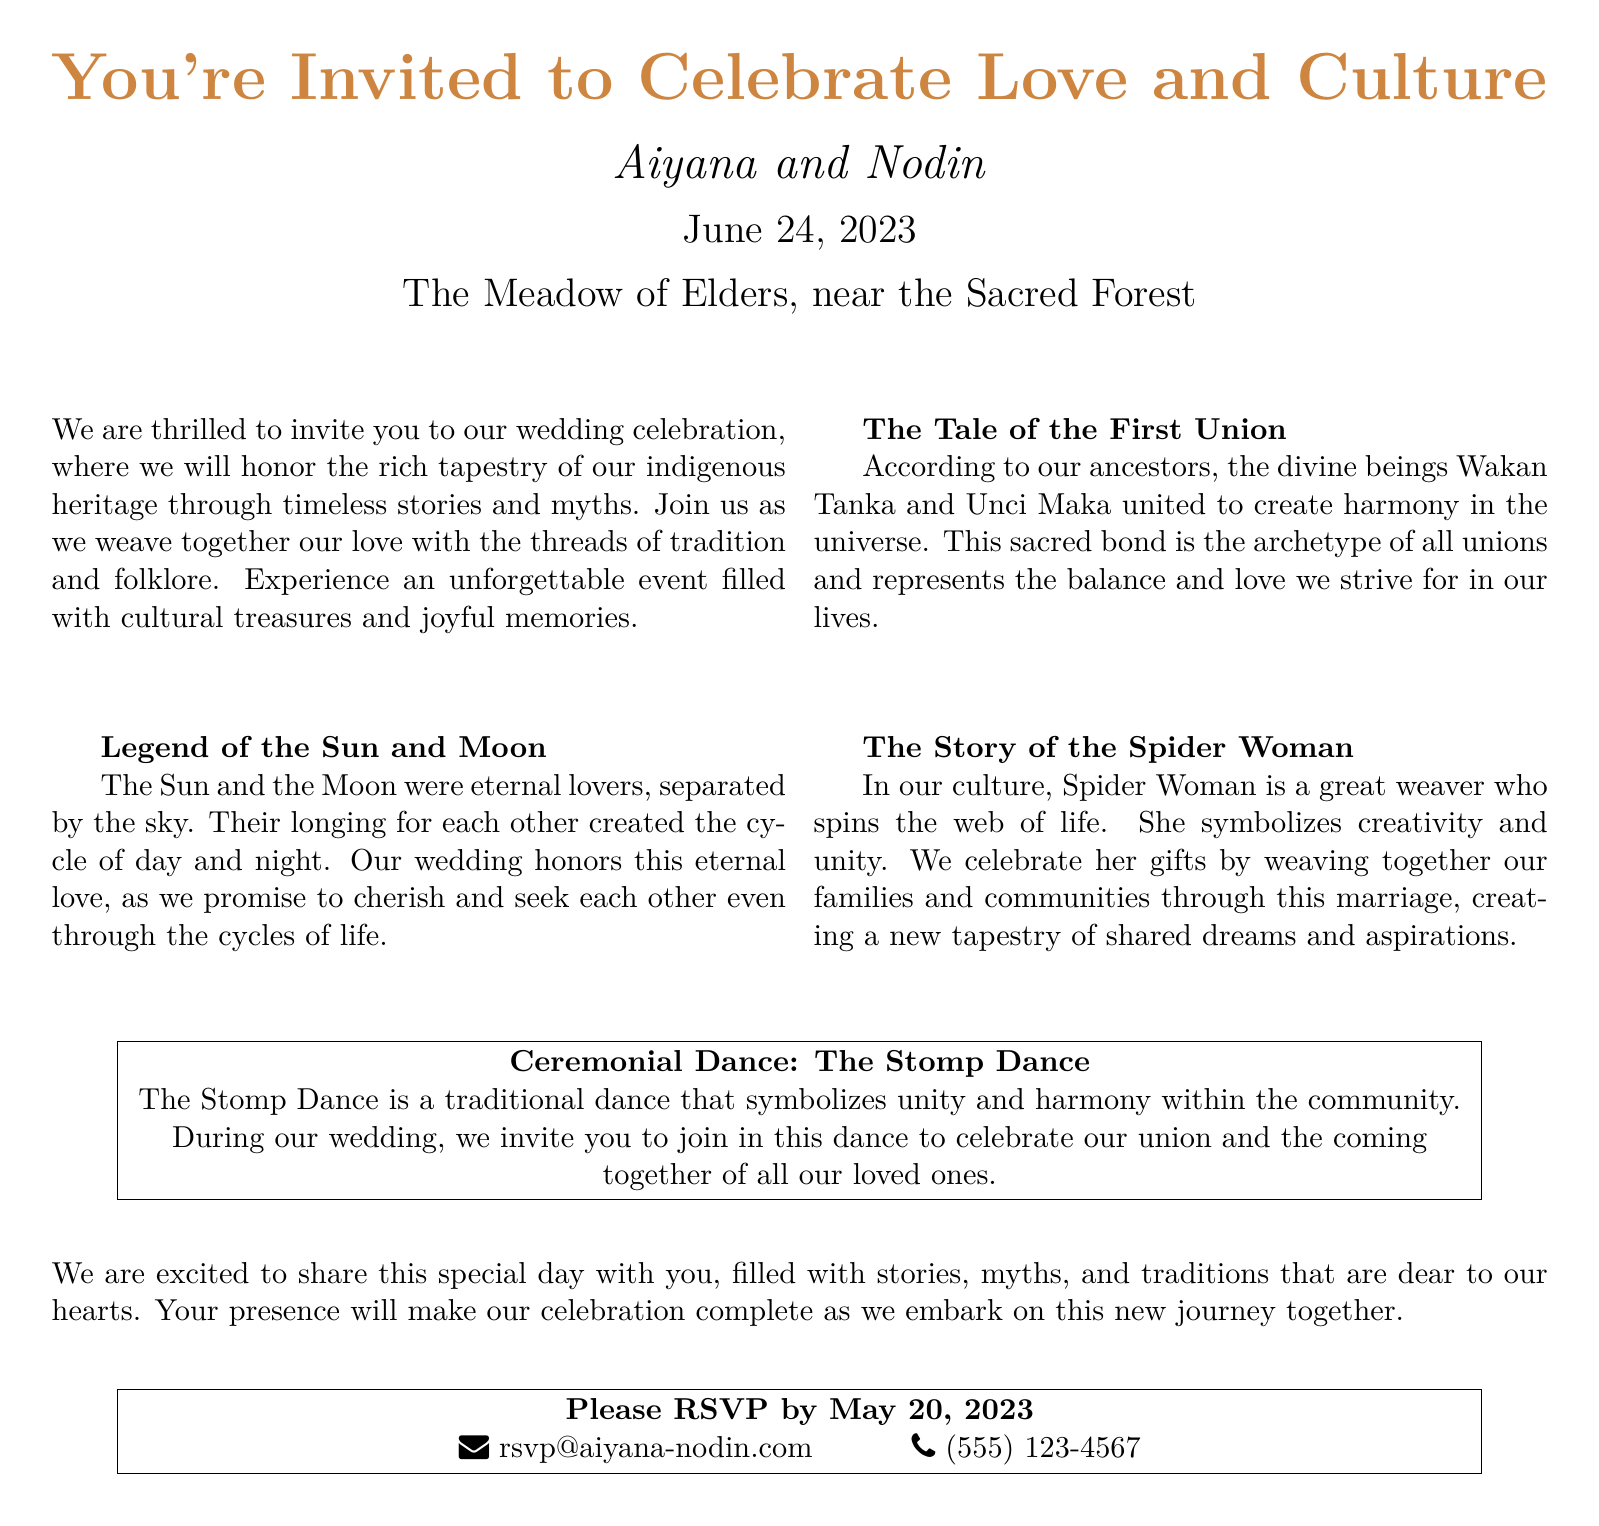What are the names of the couple getting married? The names of the couple are presented prominently at the beginning of the invitation.
Answer: Aiyana and Nodin What is the wedding date? The wedding date is explicitly stated in the invitation.
Answer: June 24, 2023 What is the venue of the wedding? The venue is mentioned in the center of the invitation.
Answer: The Meadow of Elders, near the Sacred Forest What story is related to the concept of unity in the invitation? The invitation includes a section that discusses a tale symbolizing unity and harmony.
Answer: The Tale of the First Union What traditional dance is mentioned in the document? The invitation details a specific dance that will take place during the celebration.
Answer: The Stomp Dance Why do the couple honor the cycle of day and night? The reason is explained through a myth that relates to their bond.
Answer: Eternal love When is the RSVP deadline? The RSVP deadline is clearly stated towards the end of the document.
Answer: May 20, 2023 What does Spider Woman symbolize in the invitation? The invitation explains the significance of Spider Woman in relation to the couple's marriage.
Answer: Creativity and unity What type of celebration will the couple's wedding involve? The invitation explicitly indicates the nature of the event they are celebrating.
Answer: Cultural treasures and joyful memories 